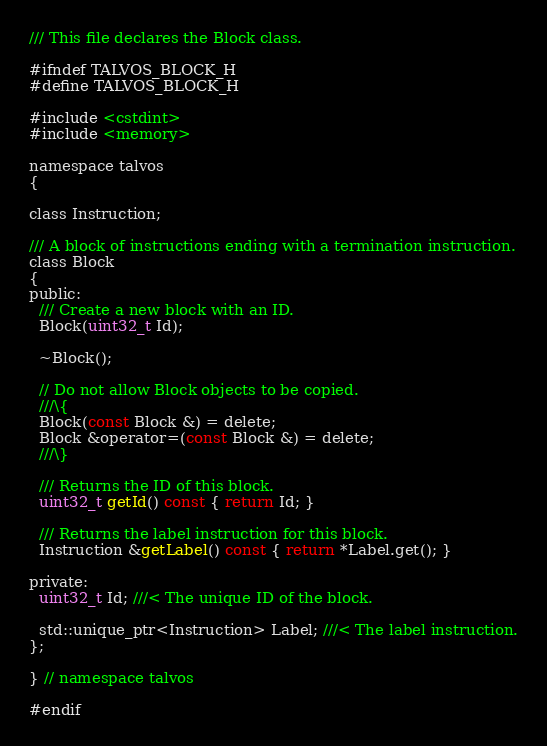<code> <loc_0><loc_0><loc_500><loc_500><_C_>/// This file declares the Block class.

#ifndef TALVOS_BLOCK_H
#define TALVOS_BLOCK_H

#include <cstdint>
#include <memory>

namespace talvos
{

class Instruction;

/// A block of instructions ending with a termination instruction.
class Block
{
public:
  /// Create a new block with an ID.
  Block(uint32_t Id);

  ~Block();

  // Do not allow Block objects to be copied.
  ///\{
  Block(const Block &) = delete;
  Block &operator=(const Block &) = delete;
  ///\}

  /// Returns the ID of this block.
  uint32_t getId() const { return Id; }

  /// Returns the label instruction for this block.
  Instruction &getLabel() const { return *Label.get(); }

private:
  uint32_t Id; ///< The unique ID of the block.

  std::unique_ptr<Instruction> Label; ///< The label instruction.
};

} // namespace talvos

#endif
</code> 